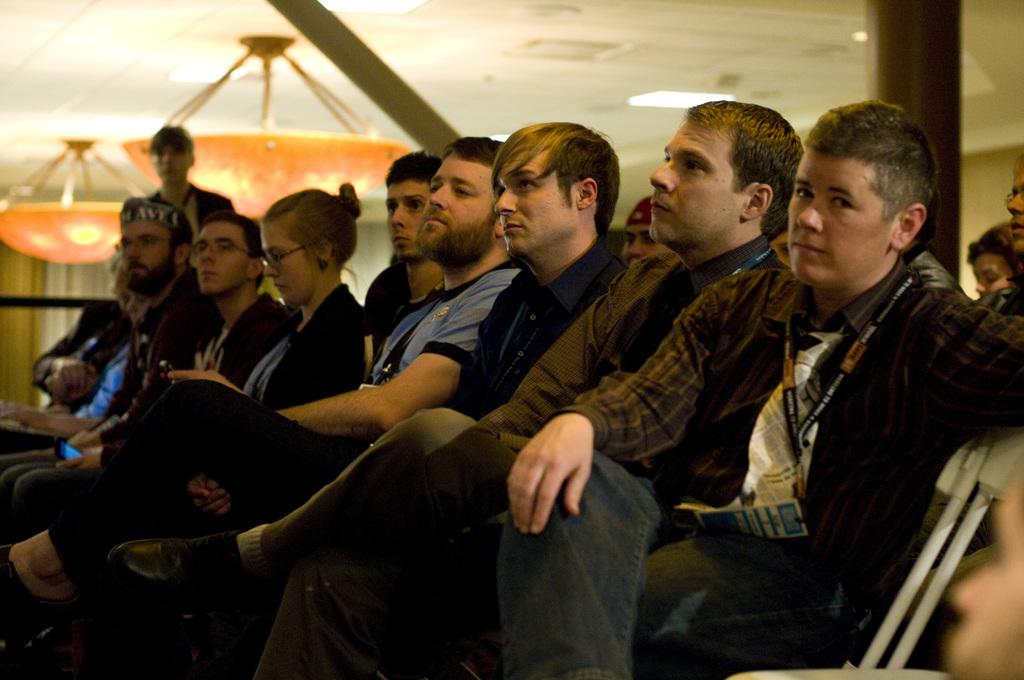What is the arrangement of people in the image? There are people sitting in a row in the image. Is there anyone standing among the sitting people? Yes, there is a person standing behind the sitting people. What can be seen in the background of the image? There are objects attached to the roof in the background of the image. Can you see any islands in the image? There are no islands visible in the image. Are there any ants crawling on the people in the image? There is no indication of ants or any other insects in the image. 